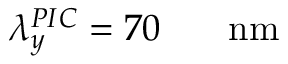<formula> <loc_0><loc_0><loc_500><loc_500>\lambda _ { y } ^ { P I C } = 7 0 { { \, } } { n m }</formula> 